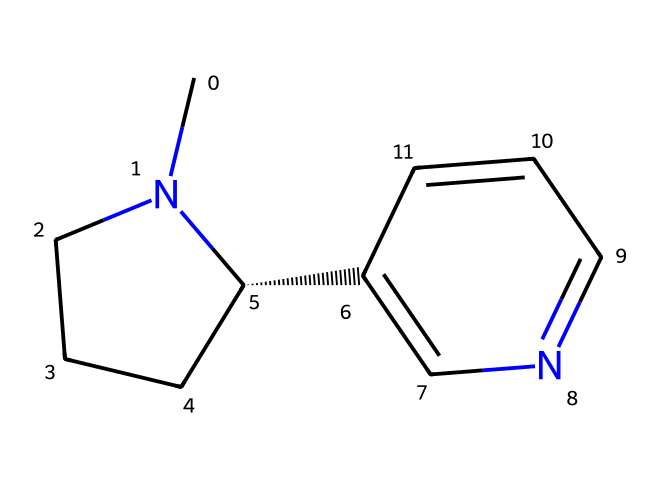How many carbon atoms are present in this structure? By analyzing the SMILES representation, we can count the number of carbon (C) atoms present in the structure. The representation indicates there are six 'C' characters in the structure.
Answer: six What type of bonds are present in this chemical structure? The SMILES representation shows both single (C-C) and double bonds (C=C) based on how the atoms are connected and represented in the notation. Thus, it contains both single and double bonds.
Answer: single and double What is the main functional group present in nicotine? The chemical structure of nicotine indicates the presence of a nitrogen atom as part of a ring structure, characteristic of alkaloids; thus, it predominantly features a pyridine ring.
Answer: pyridine ring Which type of alkaloid class does nicotine belong to? Based on the structure of nicotine, it has a heterocyclic structure with nitrogen-containing rings, characteristic of pyridine alkaloids. Hence, nicotine is classified as a pyridine alkaloid.
Answer: pyridine alkaloid How many nitrogen atoms are present in this structure? In the SMILES representation, the presence of nitrogen atoms is denoted by 'N.' Observing the notation reveals there are two 'N' characters in the chemical structure.
Answer: two What physical property do alkaloids typically exhibit based on their structure? Alkaloids, such as nicotine, are typically basic because they contain nitrogen atoms, which can accept protons due to their lone pairs, giving them basic properties.
Answer: basic How does the presence of nitrogen affect the taste of nicotine? The presence of nitrogen atoms in alkaloids contributes to a bitter taste, which is a common characteristic for many nitrogen-containing compounds including nicotine.
Answer: bitter 